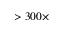<formula> <loc_0><loc_0><loc_500><loc_500>> 3 0 0 \times</formula> 